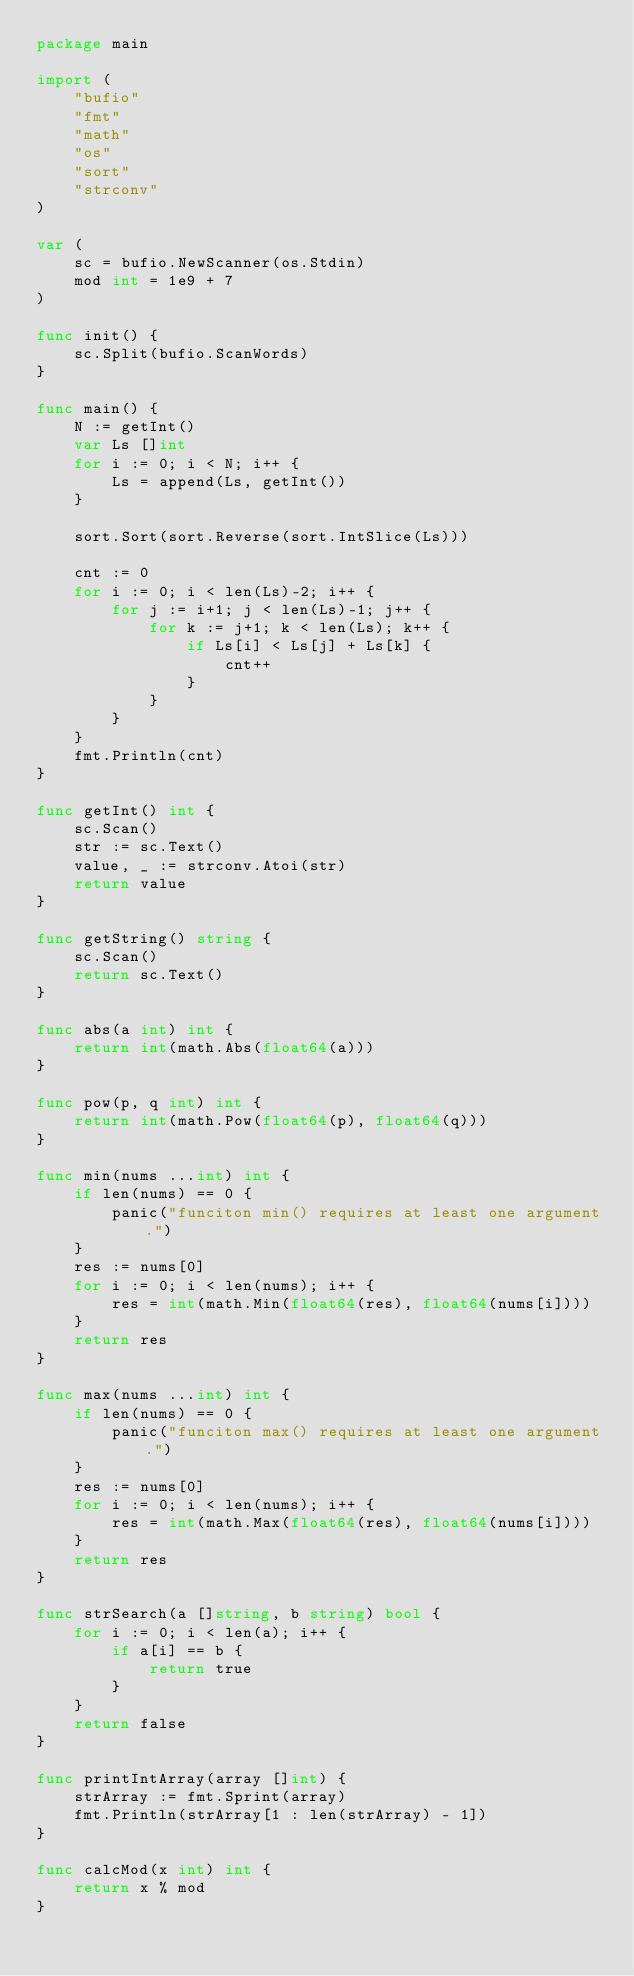Convert code to text. <code><loc_0><loc_0><loc_500><loc_500><_Go_>package main

import (
	"bufio"
	"fmt"
	"math"
	"os"
	"sort"
	"strconv"
)

var (
	sc = bufio.NewScanner(os.Stdin)
	mod int = 1e9 + 7
)

func init() {
	sc.Split(bufio.ScanWords)
}

func main() {
	N := getInt()
	var Ls []int
	for i := 0; i < N; i++ {
		Ls = append(Ls, getInt())
	}

	sort.Sort(sort.Reverse(sort.IntSlice(Ls)))

	cnt := 0
	for i := 0; i < len(Ls)-2; i++ {
		for j := i+1; j < len(Ls)-1; j++ {
			for k := j+1; k < len(Ls); k++ {
				if Ls[i] < Ls[j] + Ls[k] {
					cnt++
				}
			}
		}
	}
	fmt.Println(cnt)
}

func getInt() int {
	sc.Scan()
	str := sc.Text()
	value, _ := strconv.Atoi(str)
	return value
}

func getString() string {
	sc.Scan()
	return sc.Text()
}

func abs(a int) int {
	return int(math.Abs(float64(a)))
}

func pow(p, q int) int {
	return int(math.Pow(float64(p), float64(q)))
}

func min(nums ...int) int {
	if len(nums) == 0 {
		panic("funciton min() requires at least one argument.")
	}
	res := nums[0]
	for i := 0; i < len(nums); i++ {
		res = int(math.Min(float64(res), float64(nums[i])))
	}
	return res
}

func max(nums ...int) int {
	if len(nums) == 0 {
		panic("funciton max() requires at least one argument.")
	}
	res := nums[0]
	for i := 0; i < len(nums); i++ {
		res = int(math.Max(float64(res), float64(nums[i])))
	}
	return res
}

func strSearch(a []string, b string) bool {
	for i := 0; i < len(a); i++ {
		if a[i] == b {
			return true
		}
	}
	return false
}

func printIntArray(array []int) {
	strArray := fmt.Sprint(array)
	fmt.Println(strArray[1 : len(strArray) - 1])
}

func calcMod(x int) int {
	return x % mod
}
</code> 